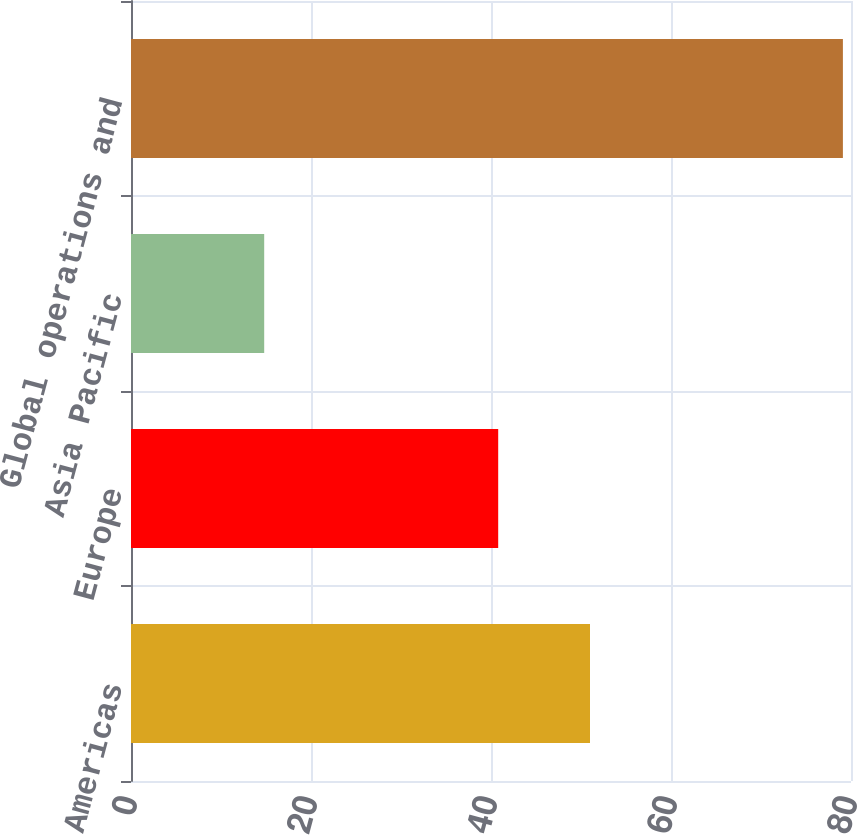Convert chart. <chart><loc_0><loc_0><loc_500><loc_500><bar_chart><fcel>Americas<fcel>Europe<fcel>Asia Pacific<fcel>Global operations and<nl><fcel>51<fcel>40.8<fcel>14.8<fcel>79.1<nl></chart> 